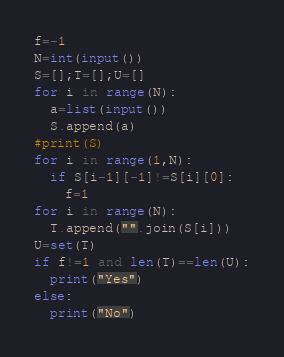Convert code to text. <code><loc_0><loc_0><loc_500><loc_500><_Python_>f=-1
N=int(input())
S=[];T=[];U=[]
for i in range(N):
  a=list(input())
  S.append(a)
#print(S)
for i in range(1,N):
  if S[i-1][-1]!=S[i][0]:
    f=1
for i in range(N):
  T.append("".join(S[i]))
U=set(T)
if f!=1 and len(T)==len(U):
  print("Yes")
else:
  print("No")</code> 